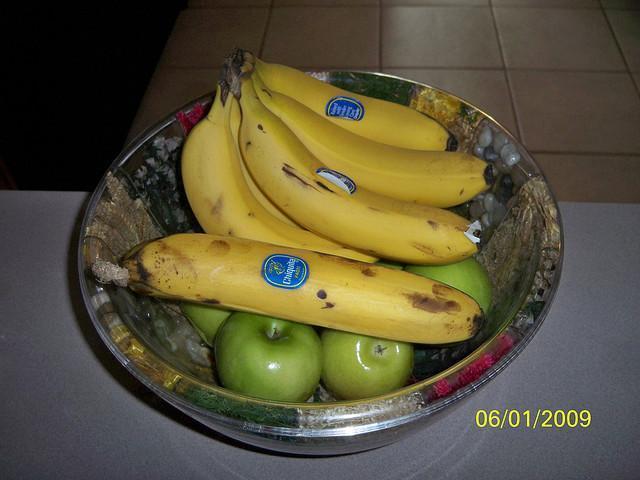How many bananas have stickers?
Give a very brief answer. 3. How many bananas?
Give a very brief answer. 6. How many bananas are visible?
Give a very brief answer. 5. How many yellow buses are there?
Give a very brief answer. 0. 